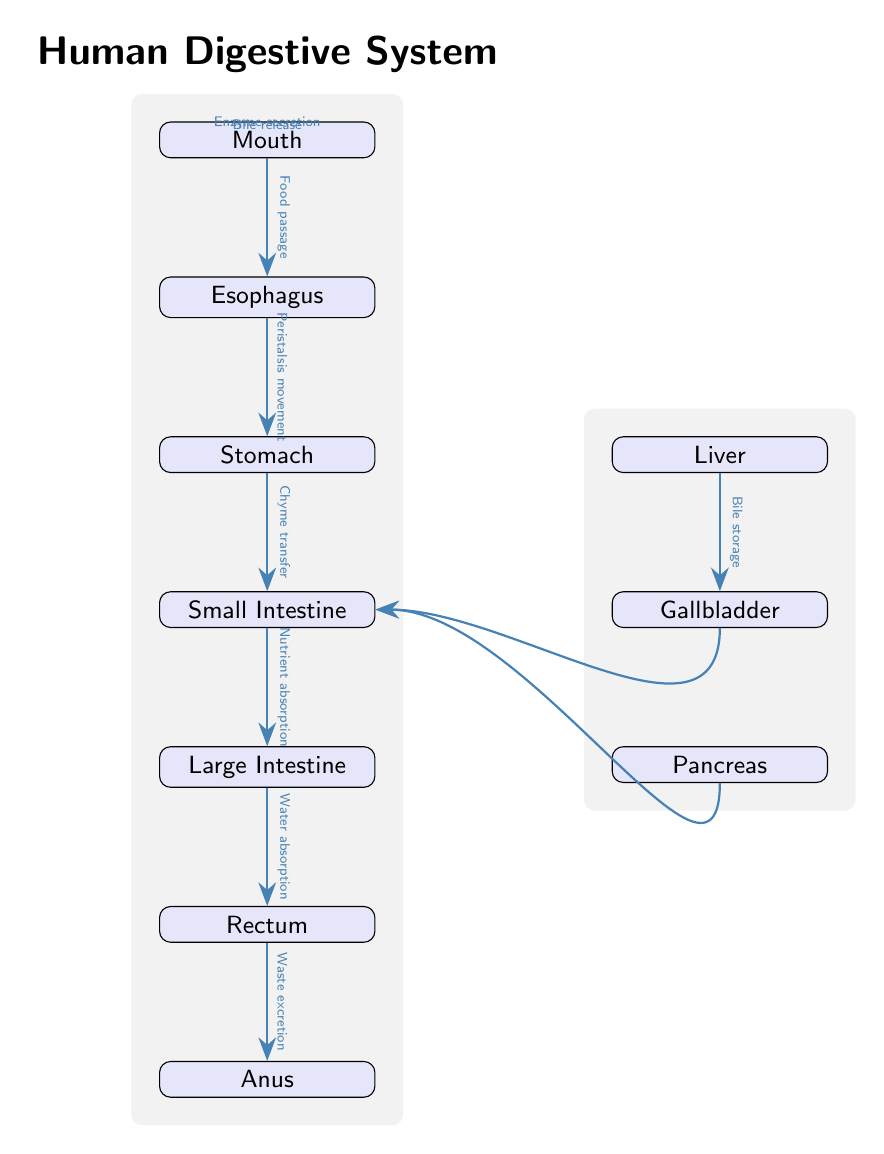What organ is located at the top of the diagram? The topmost organ is labeled as the "Mouth," which is depicted as the first node in the diagram.
Answer: Mouth How many organs are shown in the digestive system diagram? By counting the labeled organs in the vertical flow of the diagram, including the liver, gallbladder, and pancreas on the right, there are a total of 10 organs.
Answer: 10 Which organ connects the mouth to the stomach? The "Esophagus" is the organ that directly follows the mouth in the diagram, indicating its connection to the stomach.
Answer: Esophagus What type of movement does the esophagus use to transfer food? The diagram explicitly labels the movement as "Peristalsis movement," indicating the mechanism for food transfer from the esophagus to the stomach.
Answer: Peristalsis movement What is the function of the liver in relation to the gallbladder? The diagram states that the liver's function includes "Bile storage," which indicates the liver's role prior to the gallbladder.
Answer: Bile storage What is released into the small intestine from the gallbladder? The diagram specifies that "Bile release" occurs from the gallbladder to the small intestine, indicating the substance transferred.
Answer: Bile release How is nutrient absorption achieved in the digestive process? According to the diagram, "Nutrient absorption" takes place as food transitions from the small intestine to the large intestine, highlighting this specific process.
Answer: Nutrient absorption What is the final output of the digestive system as depicted in the diagram? The final organ listed after the rectum is the "Anus," where "Waste excretion" occurs, indicating the output of the digestive system.
Answer: Anus Which organ secretes enzymes directly into the small intestine? The diagram shows the "Pancreas" as the organ that has an arrow indicating "Enzyme secretion" into the small intestine.
Answer: Pancreas What process occurs in the large intestine according to the diagram? The diagram indicates the function of the large intestine as "Water absorption," detailing its role in the digestive process.
Answer: Water absorption 